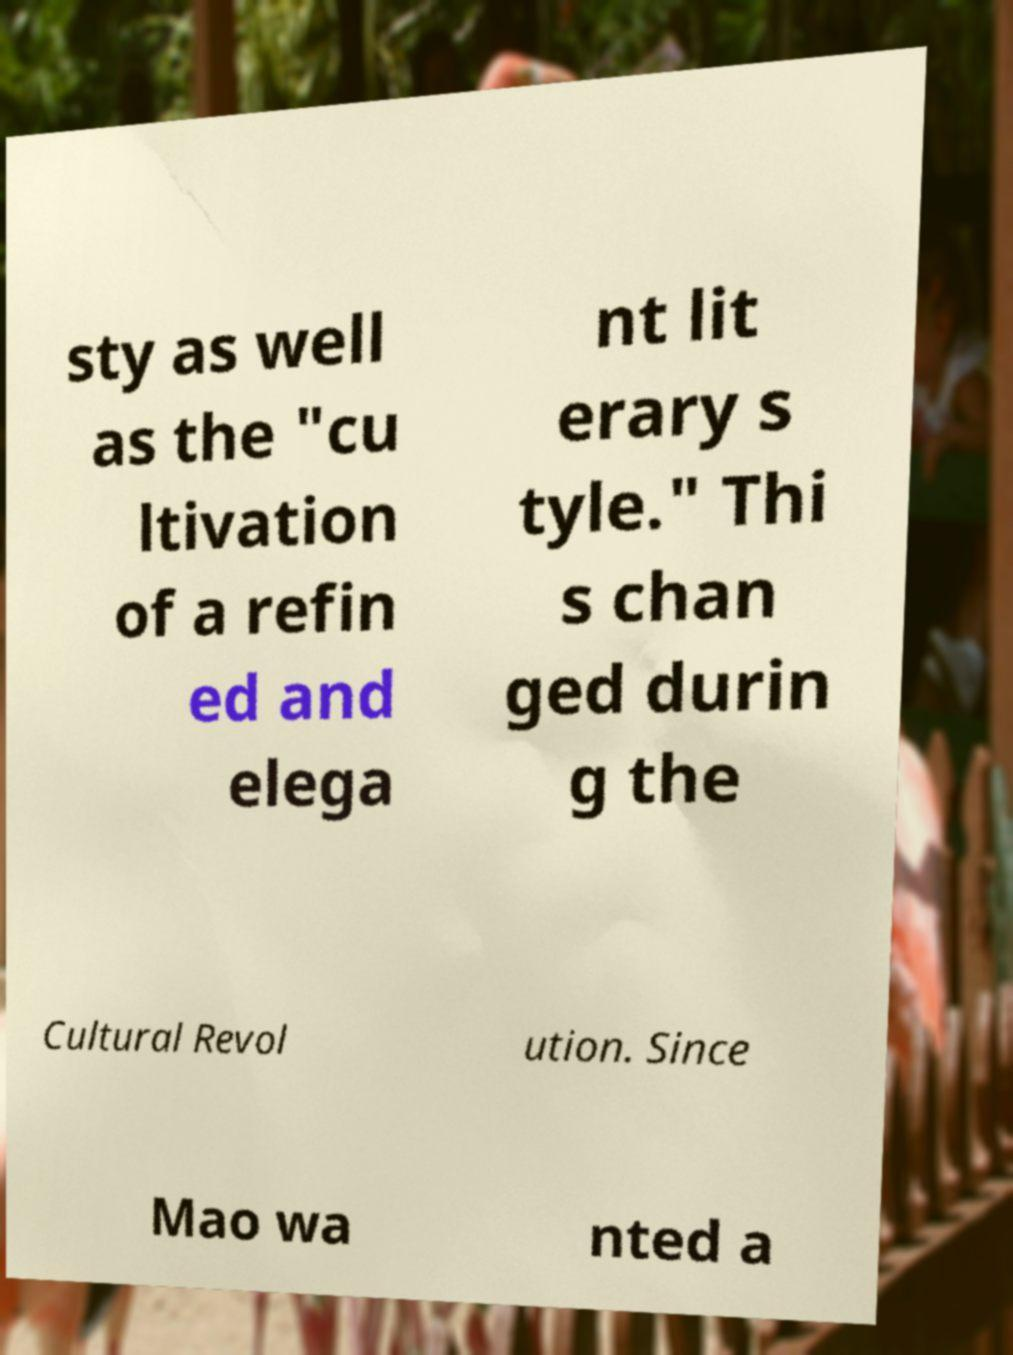Can you accurately transcribe the text from the provided image for me? sty as well as the "cu ltivation of a refin ed and elega nt lit erary s tyle." Thi s chan ged durin g the Cultural Revol ution. Since Mao wa nted a 